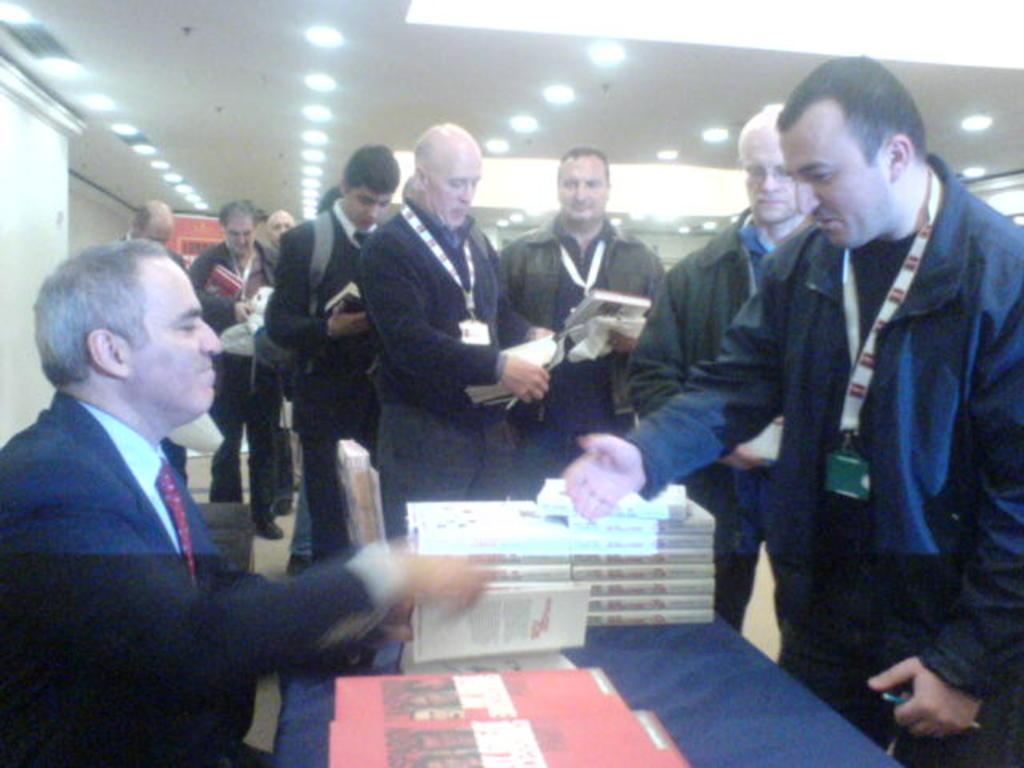What is the person in the image doing? There is a person sitting in the image. What objects can be seen on the table in the image? There are books on a table in the image. What are the people in the group doing? The people in the group are standing and holding books. What can be seen on the people in the group? The people in the group have tags. What can be seen in the image that provides illumination? There are lights visible in the image. What type of butter is being used to adjust the lights in the image? There is no butter or adjustment of lights present in the image. What type of spacecraft can be seen in the image? There is no spacecraft present in the image. 